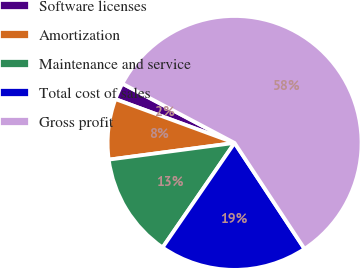<chart> <loc_0><loc_0><loc_500><loc_500><pie_chart><fcel>Software licenses<fcel>Amortization<fcel>Maintenance and service<fcel>Total cost of sales<fcel>Gross profit<nl><fcel>2.13%<fcel>7.71%<fcel>13.3%<fcel>18.88%<fcel>57.97%<nl></chart> 